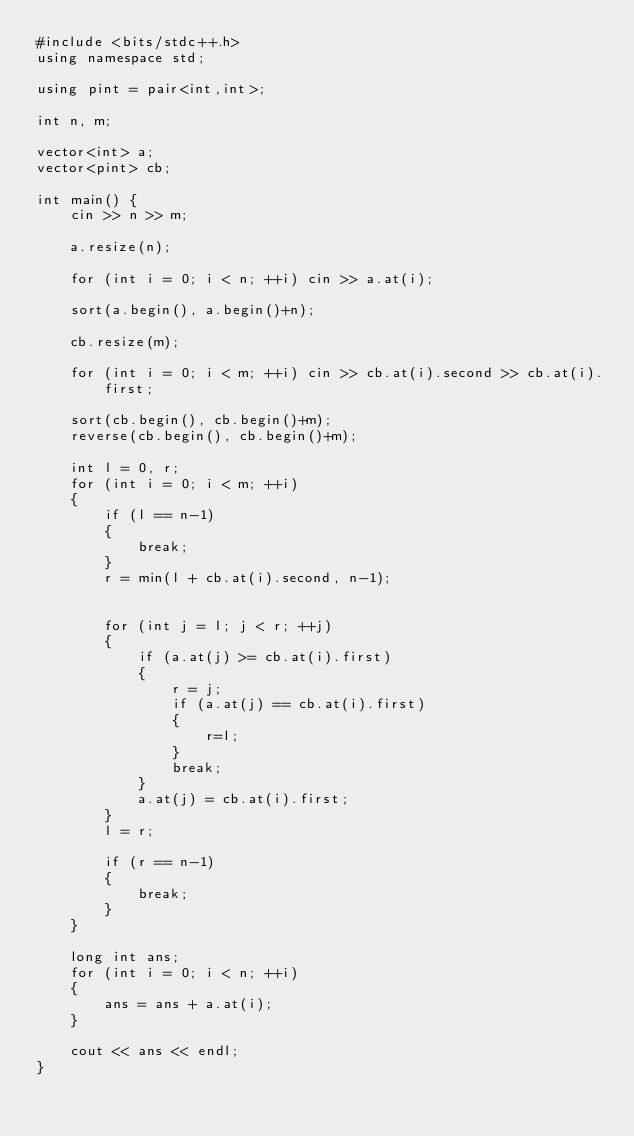<code> <loc_0><loc_0><loc_500><loc_500><_C++_>#include <bits/stdc++.h>
using namespace std;

using pint = pair<int,int>;

int n, m;

vector<int> a;
vector<pint> cb;

int main() {
    cin >> n >> m;

    a.resize(n);

    for (int i = 0; i < n; ++i) cin >> a.at(i);

    sort(a.begin(), a.begin()+n);

    cb.resize(m);

    for (int i = 0; i < m; ++i) cin >> cb.at(i).second >> cb.at(i).first;

    sort(cb.begin(), cb.begin()+m);
    reverse(cb.begin(), cb.begin()+m);

    int l = 0, r;
    for (int i = 0; i < m; ++i)
    {
        if (l == n-1)
        {
            break;
        }
        r = min(l + cb.at(i).second, n-1);


        for (int j = l; j < r; ++j)
        {
            if (a.at(j) >= cb.at(i).first)
            {
                r = j;
                if (a.at(j) == cb.at(i).first)
                {
                    r=l;
                }
                break;
            }
            a.at(j) = cb.at(i).first;
        }
        l = r;

        if (r == n-1)
        {
            break;
        }
    }

    long int ans;
    for (int i = 0; i < n; ++i)
    {
        ans = ans + a.at(i);
    }

    cout << ans << endl;
}</code> 